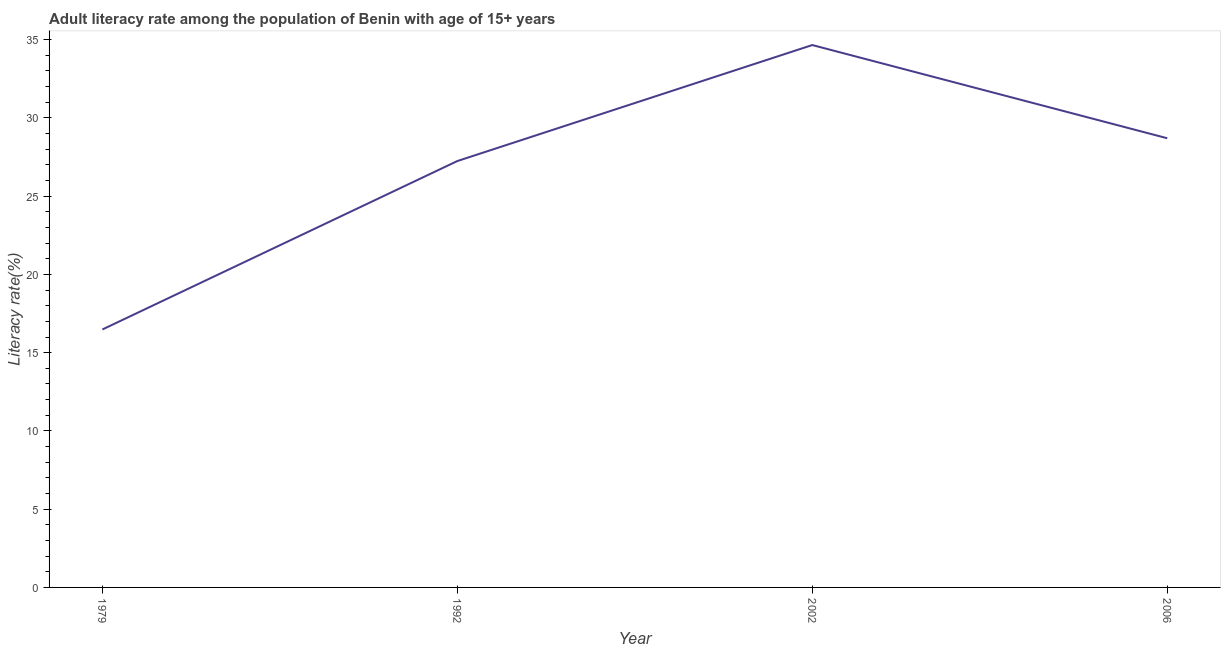What is the adult literacy rate in 1992?
Provide a succinct answer. 27.25. Across all years, what is the maximum adult literacy rate?
Your answer should be very brief. 34.66. Across all years, what is the minimum adult literacy rate?
Give a very brief answer. 16.48. In which year was the adult literacy rate maximum?
Offer a terse response. 2002. In which year was the adult literacy rate minimum?
Ensure brevity in your answer.  1979. What is the sum of the adult literacy rate?
Keep it short and to the point. 107.09. What is the difference between the adult literacy rate in 1979 and 2002?
Provide a succinct answer. -18.18. What is the average adult literacy rate per year?
Provide a short and direct response. 26.77. What is the median adult literacy rate?
Your answer should be compact. 27.97. Do a majority of the years between 1979 and 1992 (inclusive) have adult literacy rate greater than 3 %?
Provide a succinct answer. Yes. What is the ratio of the adult literacy rate in 1992 to that in 2006?
Offer a terse response. 0.95. Is the adult literacy rate in 1992 less than that in 2002?
Keep it short and to the point. Yes. What is the difference between the highest and the second highest adult literacy rate?
Make the answer very short. 5.96. Is the sum of the adult literacy rate in 1979 and 2006 greater than the maximum adult literacy rate across all years?
Provide a short and direct response. Yes. What is the difference between the highest and the lowest adult literacy rate?
Offer a very short reply. 18.18. Does the adult literacy rate monotonically increase over the years?
Provide a succinct answer. No. How many lines are there?
Your answer should be compact. 1. How many years are there in the graph?
Keep it short and to the point. 4. Does the graph contain grids?
Your response must be concise. No. What is the title of the graph?
Your response must be concise. Adult literacy rate among the population of Benin with age of 15+ years. What is the label or title of the X-axis?
Your response must be concise. Year. What is the label or title of the Y-axis?
Provide a succinct answer. Literacy rate(%). What is the Literacy rate(%) of 1979?
Provide a short and direct response. 16.48. What is the Literacy rate(%) of 1992?
Offer a terse response. 27.25. What is the Literacy rate(%) in 2002?
Provide a succinct answer. 34.66. What is the Literacy rate(%) in 2006?
Provide a succinct answer. 28.7. What is the difference between the Literacy rate(%) in 1979 and 1992?
Make the answer very short. -10.76. What is the difference between the Literacy rate(%) in 1979 and 2002?
Offer a very short reply. -18.18. What is the difference between the Literacy rate(%) in 1979 and 2006?
Your answer should be compact. -12.22. What is the difference between the Literacy rate(%) in 1992 and 2002?
Make the answer very short. -7.41. What is the difference between the Literacy rate(%) in 1992 and 2006?
Give a very brief answer. -1.46. What is the difference between the Literacy rate(%) in 2002 and 2006?
Ensure brevity in your answer.  5.96. What is the ratio of the Literacy rate(%) in 1979 to that in 1992?
Your answer should be very brief. 0.6. What is the ratio of the Literacy rate(%) in 1979 to that in 2002?
Your response must be concise. 0.48. What is the ratio of the Literacy rate(%) in 1979 to that in 2006?
Offer a very short reply. 0.57. What is the ratio of the Literacy rate(%) in 1992 to that in 2002?
Your response must be concise. 0.79. What is the ratio of the Literacy rate(%) in 1992 to that in 2006?
Ensure brevity in your answer.  0.95. What is the ratio of the Literacy rate(%) in 2002 to that in 2006?
Your answer should be compact. 1.21. 